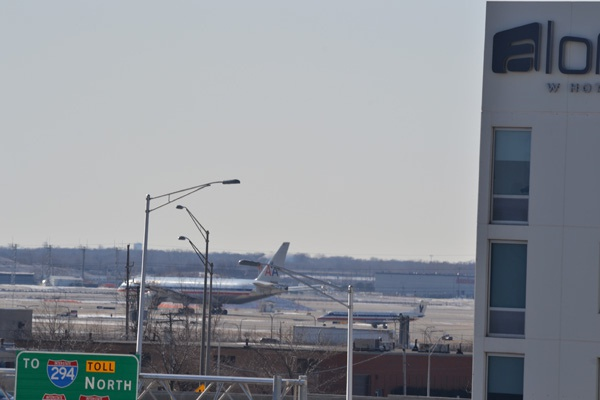Describe the objects in this image and their specific colors. I can see airplane in lightgray, gray, and darkgray tones and airplane in lightgray, gray, and darkblue tones in this image. 